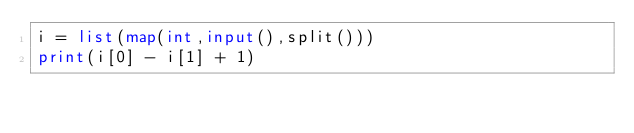Convert code to text. <code><loc_0><loc_0><loc_500><loc_500><_Python_>i = list(map(int,input(),split()))
print(i[0] - i[1] + 1)</code> 